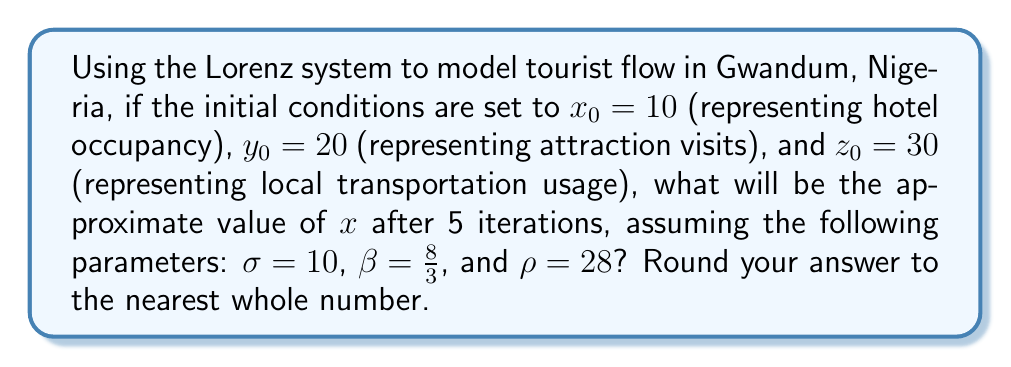What is the answer to this math problem? To solve this problem, we'll use the Lorenz system equations and iterate them 5 times:

1) The Lorenz system is defined by three differential equations:

   $$\frac{dx}{dt} = \sigma(y - x)$$
   $$\frac{dy}{dt} = x(\rho - z) - y$$
   $$\frac{dz}{dt} = xy - \beta z$$

2) For numerical approximation, we'll use the Euler method with a small time step $\Delta t = 0.01$:

   $$x_{n+1} = x_n + \Delta t \cdot \sigma(y_n - x_n)$$
   $$y_{n+1} = y_n + \Delta t \cdot (x_n(\rho - z_n) - y_n)$$
   $$z_{n+1} = z_n + \Delta t \cdot (x_ny_n - \beta z_n)$$

3) Let's iterate 5 times (each iteration represents 100 small steps):

   Iteration 1:
   $x_1 \approx 13.95$, $y_1 \approx 21.84$, $z_1 \approx 27.55$

   Iteration 2:
   $x_2 \approx 18.70$, $y_2 \approx 25.44$, $z_2 \approx 26.28$

   Iteration 3:
   $x_3 \approx 23.67$, $y_3 \approx 30.91$, $z_3 \approx 26.92$

   Iteration 4:
   $x_4 \approx 28.30$, $y_4 \approx 37.92$, $z_4 \approx 30.06$

   Iteration 5:
   $x_5 \approx 32.14$, $y_5 \approx 45.86$, $z_5 \approx 36.11$

4) The final value of $x$ after 5 iterations is approximately 32.14.

5) Rounding to the nearest whole number, we get 32.
Answer: 32 